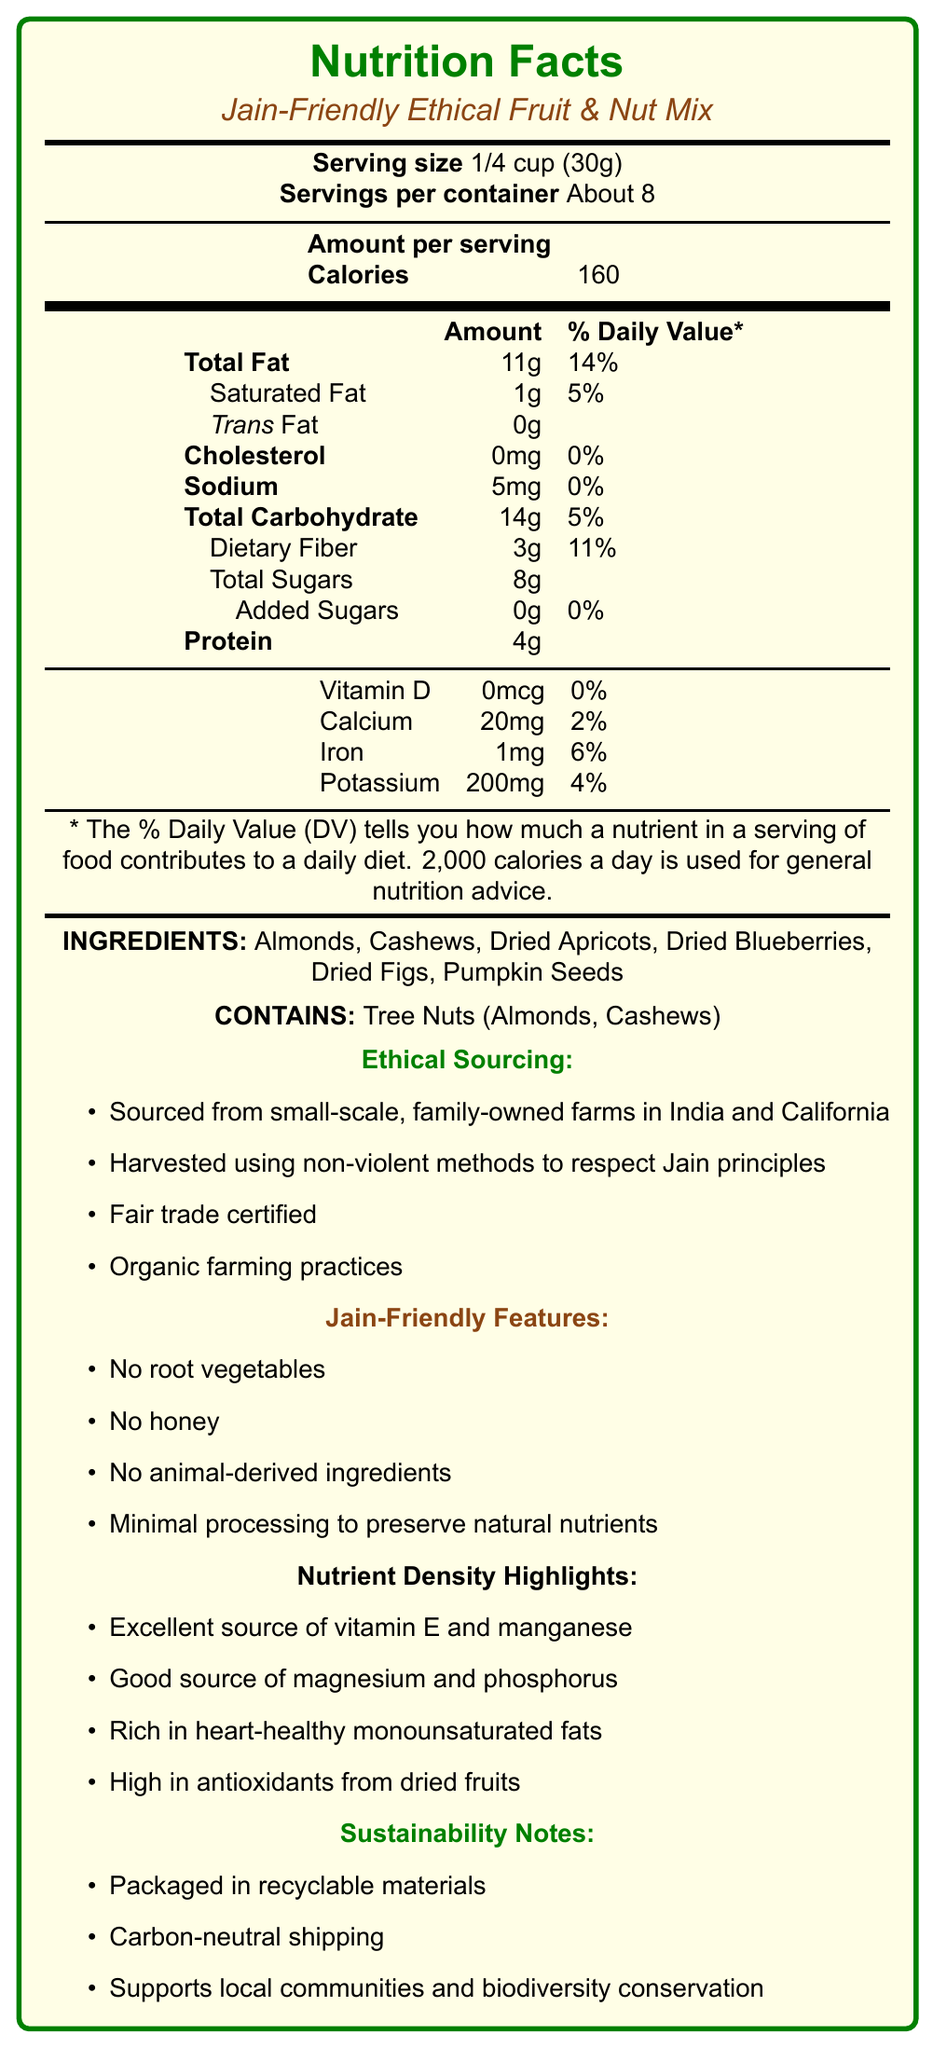what is the serving size? The serving size is listed at the beginning of the nutritional information.
Answer: 1/4 cup (30g) how many calories are in each serving? The calorie content per serving is indicated directly under the "Amount per serving" section.
Answer: 160 what is the amount of total fat in one serving? The total fat content for each serving is found in the "Total Fat" row of the table.
Answer: 11g how much dietary fiber is in a serving? The dietary fiber content per serving is indicated under the "Dietary Fiber" row within the total carbohydrate section.
Answer: 3g what are the main ingredients in the fruit & nut mix? The list of ingredients is found in the "INGREDIENTS" section right after the main nutritional table.
Answer: Almonds, Cashews, Dried Apricots, Dried Blueberries, Dried Figs, Pumpkin Seeds what percentage of the daily value of iron does one serving provide? The percentage of daily value for iron in one serving is listed in the table under the "Iron" row.
Answer: 6% how much sodium does each serving contain? The sodium content of one serving is found in its own row in the nutritional content table.
Answer: 5mg which ethical sourcing practice is mentioned specifically to respect Jain principles? This specific practice is listed in the "Ethical Sourcing" section.
Answer: Harvested using non-violent methods to respect Jain principles how much protein is in one serving? A. 2g B. 3g C. 4g The protein content of each serving is 4g, as indicated in the protein row of the nutritional content table.
Answer: C what is the amount and daily percentage of Saturated Fat in one serving? A. 1g, 5% B. 2g, 10% C. 0.5g, 3% The amount and daily percentage of Saturated Fat in one serving are 1g and 5%, respectively, as listed in the table.
Answer: A which vitamins and minerals do not have any daily percentage contribution in this mix? A. Vitamin D and Calcium B. Vitamin D and Iron C. Vitamin D and Potassium Vitamin D does not contribute to the daily value, and Potassium's daily value is 4%. However, Calcium and Iron do contribute, thus making "C" the correct answer.
Answer: C does the mix contain any added sugars? The entry for Added Sugars in the nutritional table is 0g, meaning the mix contains no added sugars.
Answer: No is this fruit & nut mix suitable for someone with tree nut allergies? The document lists "Contains: Tree Nuts (Almonds, Cashews)" under the allergens section, indicating it is not suitable for someone with tree nut allergies.
Answer: No summarize the main idea of the fruit & nut mix document. The entire document is dedicated to providing information about the nutritional content, ingredients, ethical sourcing, dietary compatibility, and sustainability features of the fruit & nut mix. It highlights that the mix is ethically sourced, Jain-friendly, rich in nutrients, and environmentally sustainable.
Answer: The document describes the nutrition facts, ingredients, ethical sourcing, Jain-friendly features, nutrient density highlights, and sustainability notes of the "Jain-Friendly Ethical Fruit & Nut Mix." It emphasizes ethical production methods, nutrient-rich composition, and suitability for Jain dietary principles, while also noting its packaging and environmental benefits. what is the shelf life of the product? The document does not provide any information about the shelf life of the fruit & nut mix.
Answer: Not enough information 